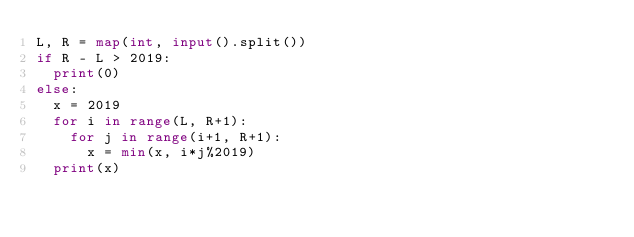Convert code to text. <code><loc_0><loc_0><loc_500><loc_500><_Python_>L, R = map(int, input().split())
if R - L > 2019:
  print(0)
else:
  x = 2019
  for i in range(L, R+1):
    for j in range(i+1, R+1):
      x = min(x, i*j%2019)
  print(x)</code> 